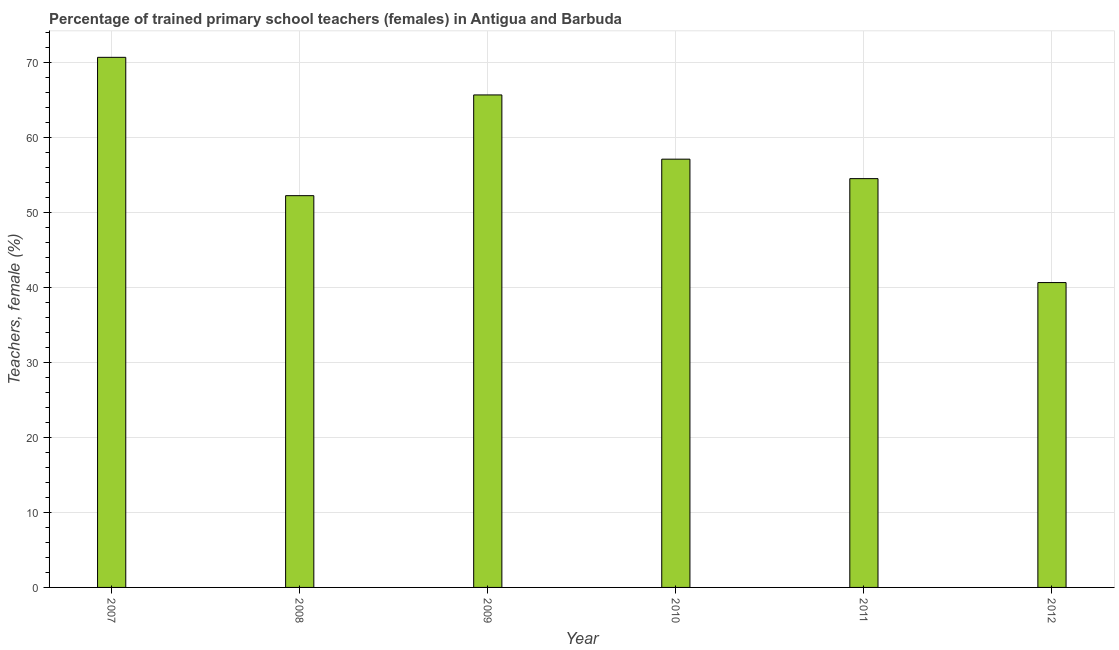What is the title of the graph?
Your response must be concise. Percentage of trained primary school teachers (females) in Antigua and Barbuda. What is the label or title of the X-axis?
Keep it short and to the point. Year. What is the label or title of the Y-axis?
Offer a terse response. Teachers, female (%). What is the percentage of trained female teachers in 2008?
Make the answer very short. 52.27. Across all years, what is the maximum percentage of trained female teachers?
Give a very brief answer. 70.73. Across all years, what is the minimum percentage of trained female teachers?
Provide a succinct answer. 40.68. What is the sum of the percentage of trained female teachers?
Give a very brief answer. 341.09. What is the difference between the percentage of trained female teachers in 2010 and 2011?
Offer a terse response. 2.6. What is the average percentage of trained female teachers per year?
Offer a terse response. 56.85. What is the median percentage of trained female teachers?
Give a very brief answer. 55.84. In how many years, is the percentage of trained female teachers greater than 12 %?
Your response must be concise. 6. Do a majority of the years between 2008 and 2010 (inclusive) have percentage of trained female teachers greater than 26 %?
Make the answer very short. Yes. What is the ratio of the percentage of trained female teachers in 2007 to that in 2012?
Offer a very short reply. 1.74. Is the difference between the percentage of trained female teachers in 2007 and 2012 greater than the difference between any two years?
Provide a succinct answer. Yes. What is the difference between the highest and the second highest percentage of trained female teachers?
Give a very brief answer. 5.02. Is the sum of the percentage of trained female teachers in 2007 and 2011 greater than the maximum percentage of trained female teachers across all years?
Ensure brevity in your answer.  Yes. What is the difference between the highest and the lowest percentage of trained female teachers?
Your response must be concise. 30.05. In how many years, is the percentage of trained female teachers greater than the average percentage of trained female teachers taken over all years?
Provide a short and direct response. 3. How many bars are there?
Ensure brevity in your answer.  6. Are all the bars in the graph horizontal?
Keep it short and to the point. No. What is the difference between two consecutive major ticks on the Y-axis?
Your answer should be very brief. 10. What is the Teachers, female (%) of 2007?
Your answer should be compact. 70.73. What is the Teachers, female (%) of 2008?
Offer a very short reply. 52.27. What is the Teachers, female (%) of 2009?
Keep it short and to the point. 65.71. What is the Teachers, female (%) of 2010?
Offer a very short reply. 57.14. What is the Teachers, female (%) in 2011?
Give a very brief answer. 54.55. What is the Teachers, female (%) in 2012?
Make the answer very short. 40.68. What is the difference between the Teachers, female (%) in 2007 and 2008?
Provide a short and direct response. 18.46. What is the difference between the Teachers, female (%) in 2007 and 2009?
Keep it short and to the point. 5.02. What is the difference between the Teachers, female (%) in 2007 and 2010?
Make the answer very short. 13.59. What is the difference between the Teachers, female (%) in 2007 and 2011?
Your answer should be compact. 16.19. What is the difference between the Teachers, female (%) in 2007 and 2012?
Keep it short and to the point. 30.05. What is the difference between the Teachers, female (%) in 2008 and 2009?
Your answer should be very brief. -13.44. What is the difference between the Teachers, female (%) in 2008 and 2010?
Provide a short and direct response. -4.87. What is the difference between the Teachers, female (%) in 2008 and 2011?
Give a very brief answer. -2.27. What is the difference between the Teachers, female (%) in 2008 and 2012?
Provide a short and direct response. 11.59. What is the difference between the Teachers, female (%) in 2009 and 2010?
Offer a very short reply. 8.57. What is the difference between the Teachers, female (%) in 2009 and 2011?
Give a very brief answer. 11.17. What is the difference between the Teachers, female (%) in 2009 and 2012?
Ensure brevity in your answer.  25.04. What is the difference between the Teachers, female (%) in 2010 and 2011?
Keep it short and to the point. 2.6. What is the difference between the Teachers, female (%) in 2010 and 2012?
Your answer should be very brief. 16.46. What is the difference between the Teachers, female (%) in 2011 and 2012?
Offer a very short reply. 13.87. What is the ratio of the Teachers, female (%) in 2007 to that in 2008?
Give a very brief answer. 1.35. What is the ratio of the Teachers, female (%) in 2007 to that in 2009?
Give a very brief answer. 1.08. What is the ratio of the Teachers, female (%) in 2007 to that in 2010?
Keep it short and to the point. 1.24. What is the ratio of the Teachers, female (%) in 2007 to that in 2011?
Your response must be concise. 1.3. What is the ratio of the Teachers, female (%) in 2007 to that in 2012?
Keep it short and to the point. 1.74. What is the ratio of the Teachers, female (%) in 2008 to that in 2009?
Provide a short and direct response. 0.8. What is the ratio of the Teachers, female (%) in 2008 to that in 2010?
Ensure brevity in your answer.  0.92. What is the ratio of the Teachers, female (%) in 2008 to that in 2011?
Offer a very short reply. 0.96. What is the ratio of the Teachers, female (%) in 2008 to that in 2012?
Offer a terse response. 1.28. What is the ratio of the Teachers, female (%) in 2009 to that in 2010?
Provide a short and direct response. 1.15. What is the ratio of the Teachers, female (%) in 2009 to that in 2011?
Ensure brevity in your answer.  1.21. What is the ratio of the Teachers, female (%) in 2009 to that in 2012?
Give a very brief answer. 1.61. What is the ratio of the Teachers, female (%) in 2010 to that in 2011?
Provide a succinct answer. 1.05. What is the ratio of the Teachers, female (%) in 2010 to that in 2012?
Ensure brevity in your answer.  1.41. What is the ratio of the Teachers, female (%) in 2011 to that in 2012?
Provide a succinct answer. 1.34. 